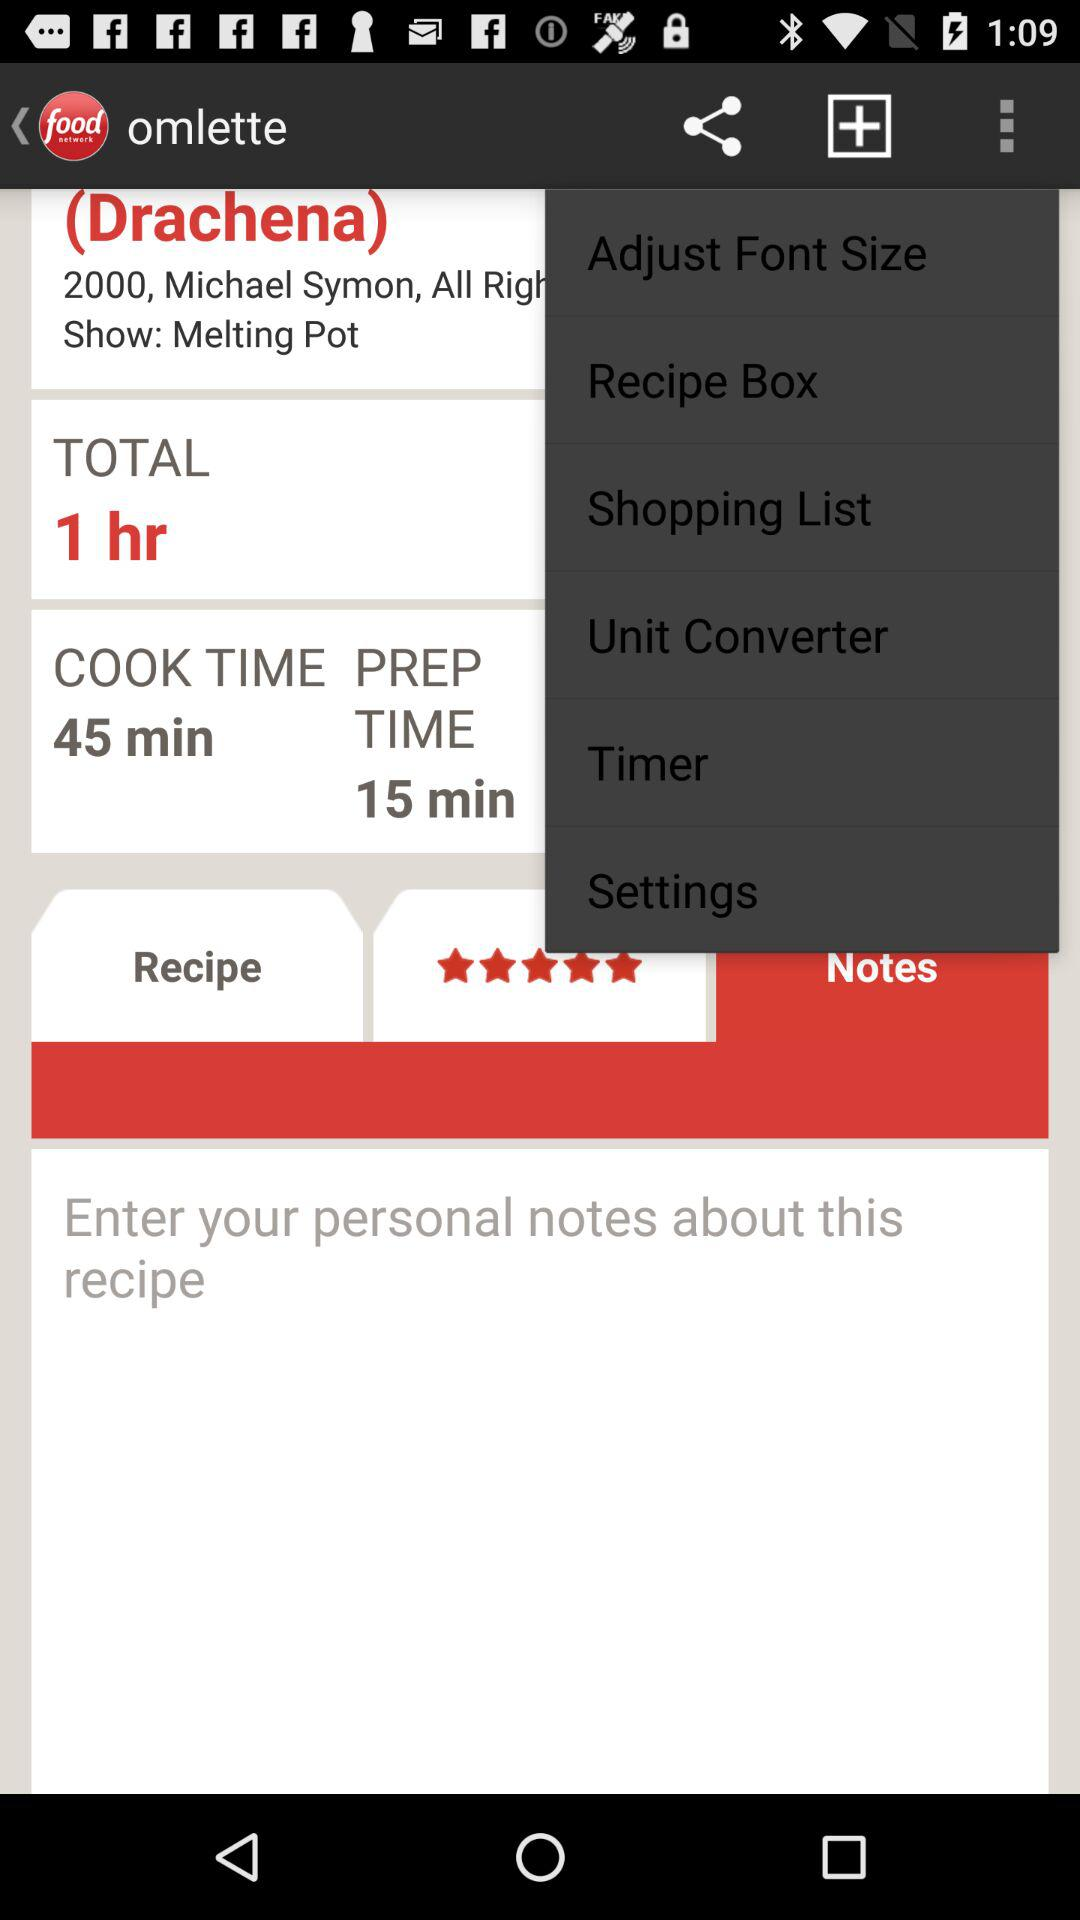What is the preparation time? The preparation time is 15 minutes. 